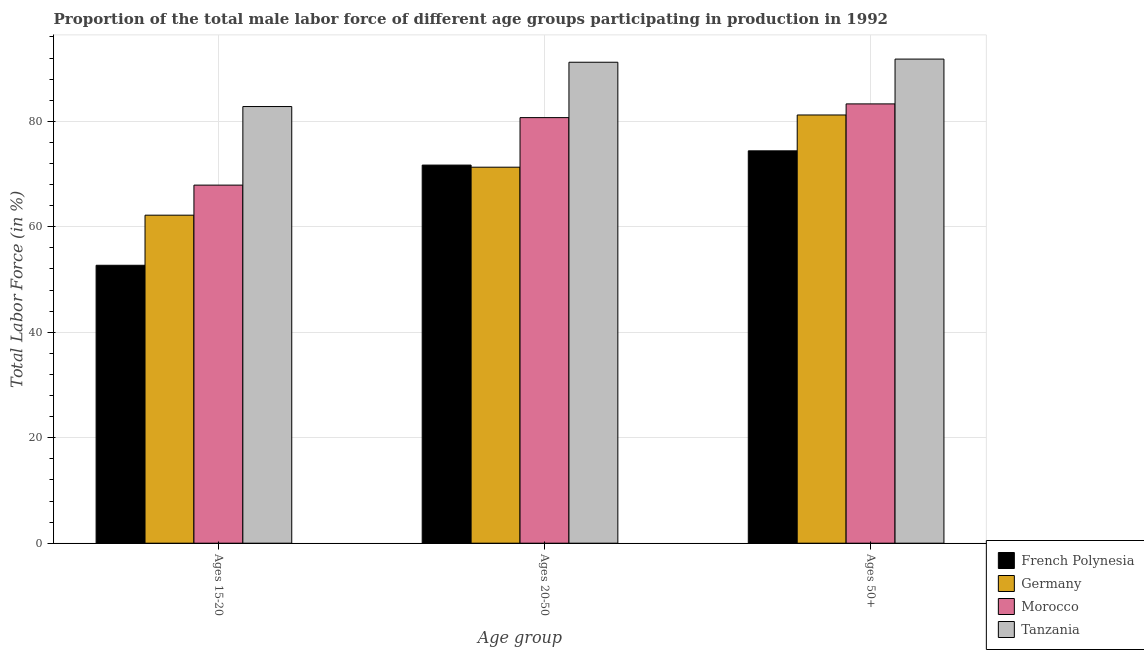How many different coloured bars are there?
Offer a terse response. 4. Are the number of bars on each tick of the X-axis equal?
Ensure brevity in your answer.  Yes. How many bars are there on the 3rd tick from the left?
Keep it short and to the point. 4. What is the label of the 2nd group of bars from the left?
Your answer should be very brief. Ages 20-50. What is the percentage of male labor force within the age group 20-50 in French Polynesia?
Offer a terse response. 71.7. Across all countries, what is the maximum percentage of male labor force within the age group 15-20?
Ensure brevity in your answer.  82.8. Across all countries, what is the minimum percentage of male labor force within the age group 20-50?
Make the answer very short. 71.3. In which country was the percentage of male labor force above age 50 maximum?
Make the answer very short. Tanzania. What is the total percentage of male labor force above age 50 in the graph?
Offer a very short reply. 330.7. What is the difference between the percentage of male labor force within the age group 15-20 in French Polynesia and that in Morocco?
Your answer should be very brief. -15.2. What is the difference between the percentage of male labor force within the age group 15-20 in Tanzania and the percentage of male labor force above age 50 in French Polynesia?
Your response must be concise. 8.4. What is the average percentage of male labor force above age 50 per country?
Your answer should be compact. 82.68. What is the difference between the percentage of male labor force above age 50 and percentage of male labor force within the age group 15-20 in Morocco?
Make the answer very short. 15.4. In how many countries, is the percentage of male labor force within the age group 20-50 greater than 4 %?
Ensure brevity in your answer.  4. What is the ratio of the percentage of male labor force within the age group 15-20 in Tanzania to that in Morocco?
Provide a short and direct response. 1.22. Is the percentage of male labor force above age 50 in Tanzania less than that in Morocco?
Keep it short and to the point. No. Is the difference between the percentage of male labor force within the age group 20-50 in Morocco and Tanzania greater than the difference between the percentage of male labor force above age 50 in Morocco and Tanzania?
Provide a short and direct response. No. What is the difference between the highest and the second highest percentage of male labor force within the age group 20-50?
Give a very brief answer. 10.5. What is the difference between the highest and the lowest percentage of male labor force within the age group 20-50?
Your answer should be compact. 19.9. In how many countries, is the percentage of male labor force within the age group 15-20 greater than the average percentage of male labor force within the age group 15-20 taken over all countries?
Give a very brief answer. 2. What does the 3rd bar from the left in Ages 50+ represents?
Make the answer very short. Morocco. What does the 2nd bar from the right in Ages 20-50 represents?
Offer a very short reply. Morocco. What is the difference between two consecutive major ticks on the Y-axis?
Your answer should be very brief. 20. Are the values on the major ticks of Y-axis written in scientific E-notation?
Your response must be concise. No. How are the legend labels stacked?
Provide a succinct answer. Vertical. What is the title of the graph?
Provide a short and direct response. Proportion of the total male labor force of different age groups participating in production in 1992. What is the label or title of the X-axis?
Your answer should be compact. Age group. What is the Total Labor Force (in %) in French Polynesia in Ages 15-20?
Your answer should be very brief. 52.7. What is the Total Labor Force (in %) of Germany in Ages 15-20?
Your response must be concise. 62.2. What is the Total Labor Force (in %) in Morocco in Ages 15-20?
Provide a succinct answer. 67.9. What is the Total Labor Force (in %) of Tanzania in Ages 15-20?
Offer a very short reply. 82.8. What is the Total Labor Force (in %) of French Polynesia in Ages 20-50?
Offer a terse response. 71.7. What is the Total Labor Force (in %) in Germany in Ages 20-50?
Offer a terse response. 71.3. What is the Total Labor Force (in %) of Morocco in Ages 20-50?
Provide a short and direct response. 80.7. What is the Total Labor Force (in %) of Tanzania in Ages 20-50?
Provide a short and direct response. 91.2. What is the Total Labor Force (in %) of French Polynesia in Ages 50+?
Offer a terse response. 74.4. What is the Total Labor Force (in %) of Germany in Ages 50+?
Give a very brief answer. 81.2. What is the Total Labor Force (in %) of Morocco in Ages 50+?
Make the answer very short. 83.3. What is the Total Labor Force (in %) of Tanzania in Ages 50+?
Offer a very short reply. 91.8. Across all Age group, what is the maximum Total Labor Force (in %) in French Polynesia?
Your response must be concise. 74.4. Across all Age group, what is the maximum Total Labor Force (in %) in Germany?
Make the answer very short. 81.2. Across all Age group, what is the maximum Total Labor Force (in %) of Morocco?
Your answer should be very brief. 83.3. Across all Age group, what is the maximum Total Labor Force (in %) of Tanzania?
Keep it short and to the point. 91.8. Across all Age group, what is the minimum Total Labor Force (in %) in French Polynesia?
Give a very brief answer. 52.7. Across all Age group, what is the minimum Total Labor Force (in %) of Germany?
Offer a very short reply. 62.2. Across all Age group, what is the minimum Total Labor Force (in %) of Morocco?
Offer a terse response. 67.9. Across all Age group, what is the minimum Total Labor Force (in %) in Tanzania?
Offer a terse response. 82.8. What is the total Total Labor Force (in %) of French Polynesia in the graph?
Provide a short and direct response. 198.8. What is the total Total Labor Force (in %) of Germany in the graph?
Your answer should be very brief. 214.7. What is the total Total Labor Force (in %) in Morocco in the graph?
Offer a terse response. 231.9. What is the total Total Labor Force (in %) of Tanzania in the graph?
Provide a succinct answer. 265.8. What is the difference between the Total Labor Force (in %) in French Polynesia in Ages 15-20 and that in Ages 20-50?
Offer a very short reply. -19. What is the difference between the Total Labor Force (in %) in Germany in Ages 15-20 and that in Ages 20-50?
Ensure brevity in your answer.  -9.1. What is the difference between the Total Labor Force (in %) in Tanzania in Ages 15-20 and that in Ages 20-50?
Make the answer very short. -8.4. What is the difference between the Total Labor Force (in %) of French Polynesia in Ages 15-20 and that in Ages 50+?
Provide a succinct answer. -21.7. What is the difference between the Total Labor Force (in %) in Morocco in Ages 15-20 and that in Ages 50+?
Provide a succinct answer. -15.4. What is the difference between the Total Labor Force (in %) of French Polynesia in Ages 20-50 and that in Ages 50+?
Your answer should be compact. -2.7. What is the difference between the Total Labor Force (in %) of Morocco in Ages 20-50 and that in Ages 50+?
Offer a terse response. -2.6. What is the difference between the Total Labor Force (in %) of Tanzania in Ages 20-50 and that in Ages 50+?
Offer a very short reply. -0.6. What is the difference between the Total Labor Force (in %) in French Polynesia in Ages 15-20 and the Total Labor Force (in %) in Germany in Ages 20-50?
Provide a succinct answer. -18.6. What is the difference between the Total Labor Force (in %) of French Polynesia in Ages 15-20 and the Total Labor Force (in %) of Morocco in Ages 20-50?
Offer a terse response. -28. What is the difference between the Total Labor Force (in %) in French Polynesia in Ages 15-20 and the Total Labor Force (in %) in Tanzania in Ages 20-50?
Make the answer very short. -38.5. What is the difference between the Total Labor Force (in %) of Germany in Ages 15-20 and the Total Labor Force (in %) of Morocco in Ages 20-50?
Provide a succinct answer. -18.5. What is the difference between the Total Labor Force (in %) of Morocco in Ages 15-20 and the Total Labor Force (in %) of Tanzania in Ages 20-50?
Provide a short and direct response. -23.3. What is the difference between the Total Labor Force (in %) in French Polynesia in Ages 15-20 and the Total Labor Force (in %) in Germany in Ages 50+?
Provide a short and direct response. -28.5. What is the difference between the Total Labor Force (in %) in French Polynesia in Ages 15-20 and the Total Labor Force (in %) in Morocco in Ages 50+?
Give a very brief answer. -30.6. What is the difference between the Total Labor Force (in %) of French Polynesia in Ages 15-20 and the Total Labor Force (in %) of Tanzania in Ages 50+?
Provide a short and direct response. -39.1. What is the difference between the Total Labor Force (in %) in Germany in Ages 15-20 and the Total Labor Force (in %) in Morocco in Ages 50+?
Make the answer very short. -21.1. What is the difference between the Total Labor Force (in %) of Germany in Ages 15-20 and the Total Labor Force (in %) of Tanzania in Ages 50+?
Keep it short and to the point. -29.6. What is the difference between the Total Labor Force (in %) of Morocco in Ages 15-20 and the Total Labor Force (in %) of Tanzania in Ages 50+?
Provide a succinct answer. -23.9. What is the difference between the Total Labor Force (in %) in French Polynesia in Ages 20-50 and the Total Labor Force (in %) in Tanzania in Ages 50+?
Give a very brief answer. -20.1. What is the difference between the Total Labor Force (in %) in Germany in Ages 20-50 and the Total Labor Force (in %) in Morocco in Ages 50+?
Make the answer very short. -12. What is the difference between the Total Labor Force (in %) of Germany in Ages 20-50 and the Total Labor Force (in %) of Tanzania in Ages 50+?
Your response must be concise. -20.5. What is the difference between the Total Labor Force (in %) of Morocco in Ages 20-50 and the Total Labor Force (in %) of Tanzania in Ages 50+?
Ensure brevity in your answer.  -11.1. What is the average Total Labor Force (in %) in French Polynesia per Age group?
Offer a terse response. 66.27. What is the average Total Labor Force (in %) of Germany per Age group?
Keep it short and to the point. 71.57. What is the average Total Labor Force (in %) of Morocco per Age group?
Keep it short and to the point. 77.3. What is the average Total Labor Force (in %) of Tanzania per Age group?
Your response must be concise. 88.6. What is the difference between the Total Labor Force (in %) in French Polynesia and Total Labor Force (in %) in Germany in Ages 15-20?
Offer a terse response. -9.5. What is the difference between the Total Labor Force (in %) of French Polynesia and Total Labor Force (in %) of Morocco in Ages 15-20?
Your response must be concise. -15.2. What is the difference between the Total Labor Force (in %) in French Polynesia and Total Labor Force (in %) in Tanzania in Ages 15-20?
Keep it short and to the point. -30.1. What is the difference between the Total Labor Force (in %) of Germany and Total Labor Force (in %) of Morocco in Ages 15-20?
Offer a terse response. -5.7. What is the difference between the Total Labor Force (in %) of Germany and Total Labor Force (in %) of Tanzania in Ages 15-20?
Ensure brevity in your answer.  -20.6. What is the difference between the Total Labor Force (in %) in Morocco and Total Labor Force (in %) in Tanzania in Ages 15-20?
Offer a very short reply. -14.9. What is the difference between the Total Labor Force (in %) in French Polynesia and Total Labor Force (in %) in Germany in Ages 20-50?
Provide a short and direct response. 0.4. What is the difference between the Total Labor Force (in %) in French Polynesia and Total Labor Force (in %) in Morocco in Ages 20-50?
Your answer should be very brief. -9. What is the difference between the Total Labor Force (in %) in French Polynesia and Total Labor Force (in %) in Tanzania in Ages 20-50?
Your answer should be compact. -19.5. What is the difference between the Total Labor Force (in %) of Germany and Total Labor Force (in %) of Morocco in Ages 20-50?
Keep it short and to the point. -9.4. What is the difference between the Total Labor Force (in %) in Germany and Total Labor Force (in %) in Tanzania in Ages 20-50?
Offer a very short reply. -19.9. What is the difference between the Total Labor Force (in %) of French Polynesia and Total Labor Force (in %) of Morocco in Ages 50+?
Provide a short and direct response. -8.9. What is the difference between the Total Labor Force (in %) in French Polynesia and Total Labor Force (in %) in Tanzania in Ages 50+?
Your answer should be very brief. -17.4. What is the difference between the Total Labor Force (in %) in Germany and Total Labor Force (in %) in Tanzania in Ages 50+?
Give a very brief answer. -10.6. What is the ratio of the Total Labor Force (in %) in French Polynesia in Ages 15-20 to that in Ages 20-50?
Keep it short and to the point. 0.73. What is the ratio of the Total Labor Force (in %) in Germany in Ages 15-20 to that in Ages 20-50?
Provide a short and direct response. 0.87. What is the ratio of the Total Labor Force (in %) of Morocco in Ages 15-20 to that in Ages 20-50?
Provide a short and direct response. 0.84. What is the ratio of the Total Labor Force (in %) of Tanzania in Ages 15-20 to that in Ages 20-50?
Offer a very short reply. 0.91. What is the ratio of the Total Labor Force (in %) in French Polynesia in Ages 15-20 to that in Ages 50+?
Ensure brevity in your answer.  0.71. What is the ratio of the Total Labor Force (in %) in Germany in Ages 15-20 to that in Ages 50+?
Offer a very short reply. 0.77. What is the ratio of the Total Labor Force (in %) of Morocco in Ages 15-20 to that in Ages 50+?
Offer a very short reply. 0.82. What is the ratio of the Total Labor Force (in %) of Tanzania in Ages 15-20 to that in Ages 50+?
Ensure brevity in your answer.  0.9. What is the ratio of the Total Labor Force (in %) of French Polynesia in Ages 20-50 to that in Ages 50+?
Your answer should be very brief. 0.96. What is the ratio of the Total Labor Force (in %) in Germany in Ages 20-50 to that in Ages 50+?
Your response must be concise. 0.88. What is the ratio of the Total Labor Force (in %) in Morocco in Ages 20-50 to that in Ages 50+?
Your response must be concise. 0.97. What is the ratio of the Total Labor Force (in %) of Tanzania in Ages 20-50 to that in Ages 50+?
Ensure brevity in your answer.  0.99. What is the difference between the highest and the second highest Total Labor Force (in %) of French Polynesia?
Provide a succinct answer. 2.7. What is the difference between the highest and the lowest Total Labor Force (in %) of French Polynesia?
Give a very brief answer. 21.7. What is the difference between the highest and the lowest Total Labor Force (in %) in Germany?
Offer a very short reply. 19. What is the difference between the highest and the lowest Total Labor Force (in %) in Morocco?
Offer a very short reply. 15.4. 